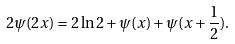Convert formula to latex. <formula><loc_0><loc_0><loc_500><loc_500>2 \psi ( 2 x ) = 2 \ln 2 + \psi ( x ) + \psi ( x + \frac { 1 } { 2 } ) .</formula> 